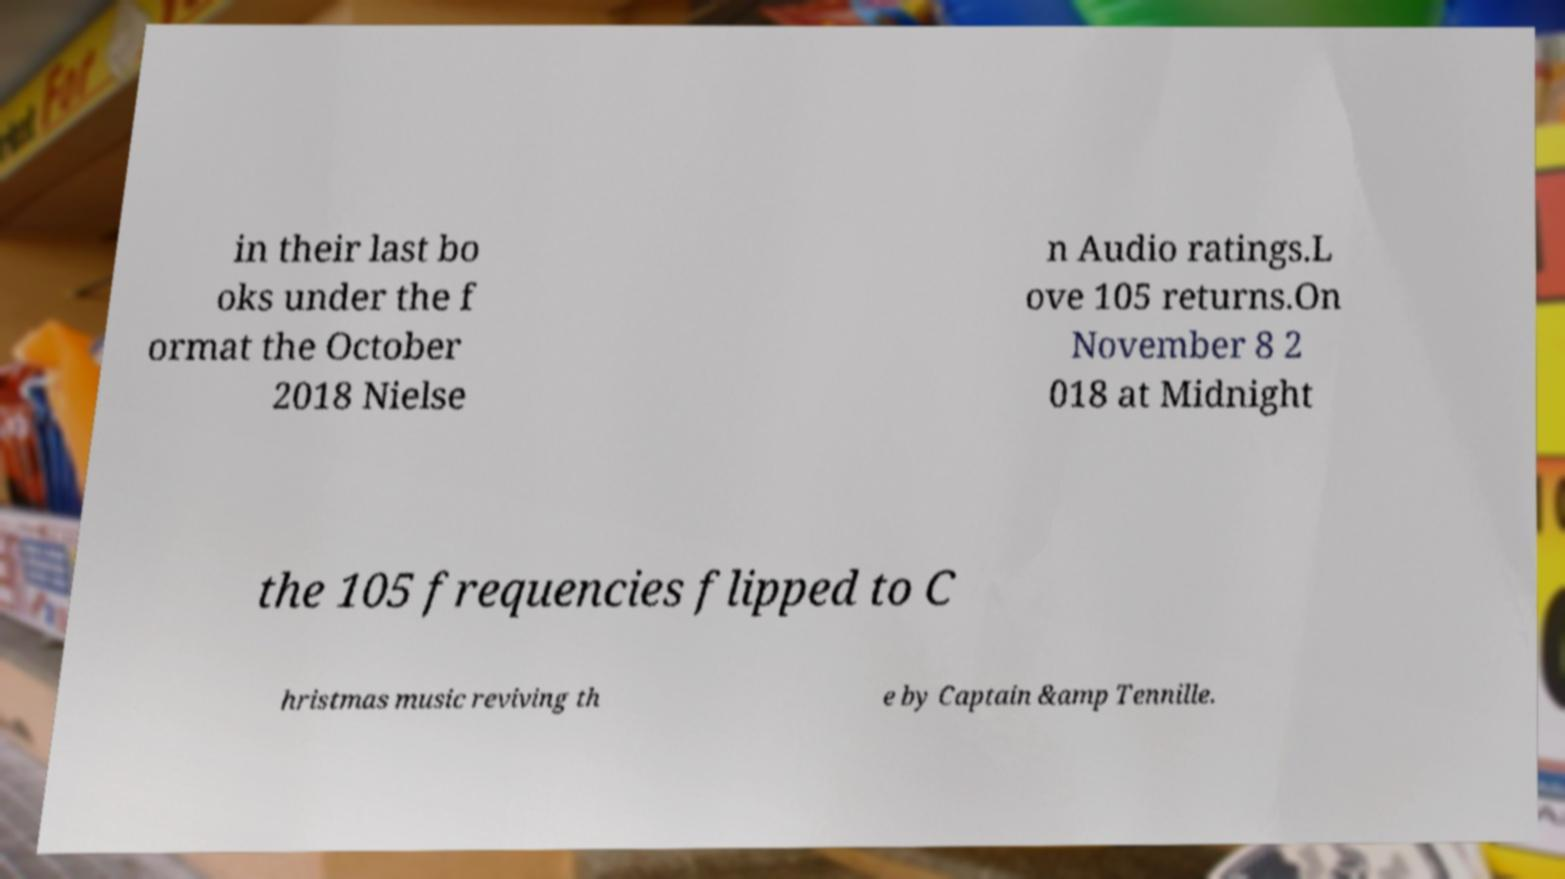Please read and relay the text visible in this image. What does it say? in their last bo oks under the f ormat the October 2018 Nielse n Audio ratings.L ove 105 returns.On November 8 2 018 at Midnight the 105 frequencies flipped to C hristmas music reviving th e by Captain &amp Tennille. 